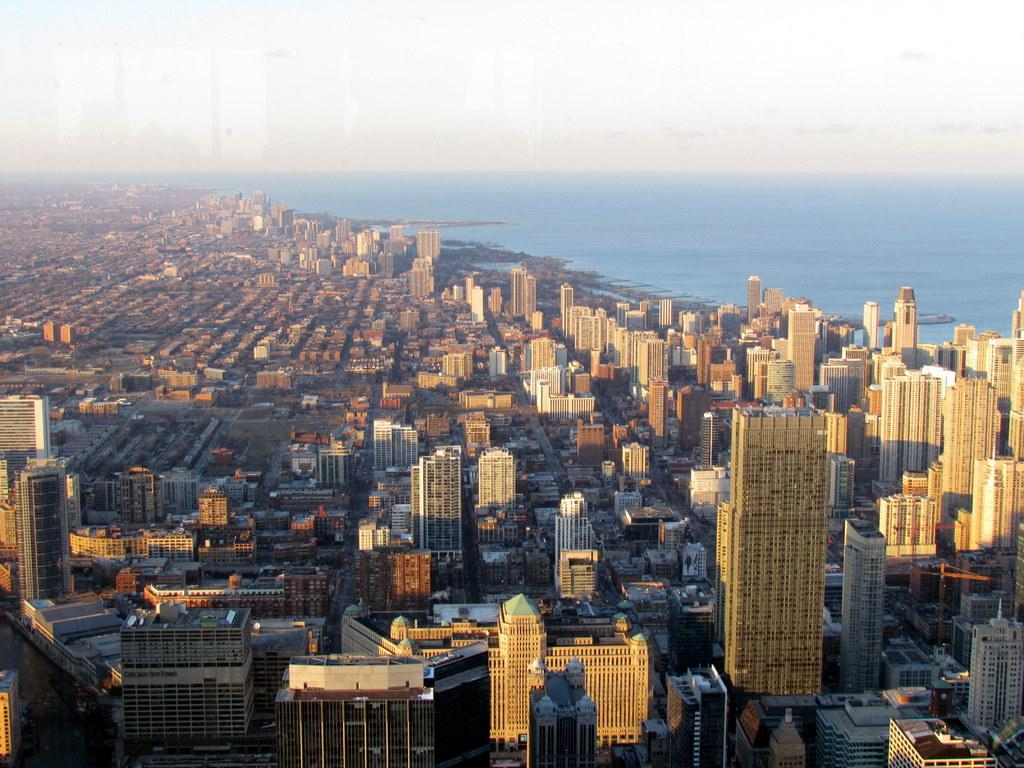What type of view is shown in the image? The image is an aerial view of a city. What structures can be seen in the city? There are buildings and skyscrapers in the city. How densely populated is the land in the image? The land is covered with buildings and skyscrapers. What natural feature is visible in the image? There is an ocean visible in the image. What part of the sky is visible in the image? The sky is visible in the image. Where is the cave located in the image? There is no cave present in the image; it is an aerial view of a city with buildings, skyscrapers, an ocean, and the sky. 